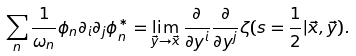<formula> <loc_0><loc_0><loc_500><loc_500>\sum _ { n } \frac { 1 } { \omega _ { n } } \phi _ { n } \partial _ { i } \partial _ { j } \phi _ { n } ^ { * } = \lim _ { \vec { y } \rightarrow \vec { x } } \frac { \partial } { \partial y ^ { i } } \frac { \partial } { \partial y ^ { j } } \zeta ( s = \frac { 1 } { 2 } | \vec { x } , \vec { y } ) .</formula> 